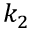Convert formula to latex. <formula><loc_0><loc_0><loc_500><loc_500>k _ { 2 }</formula> 